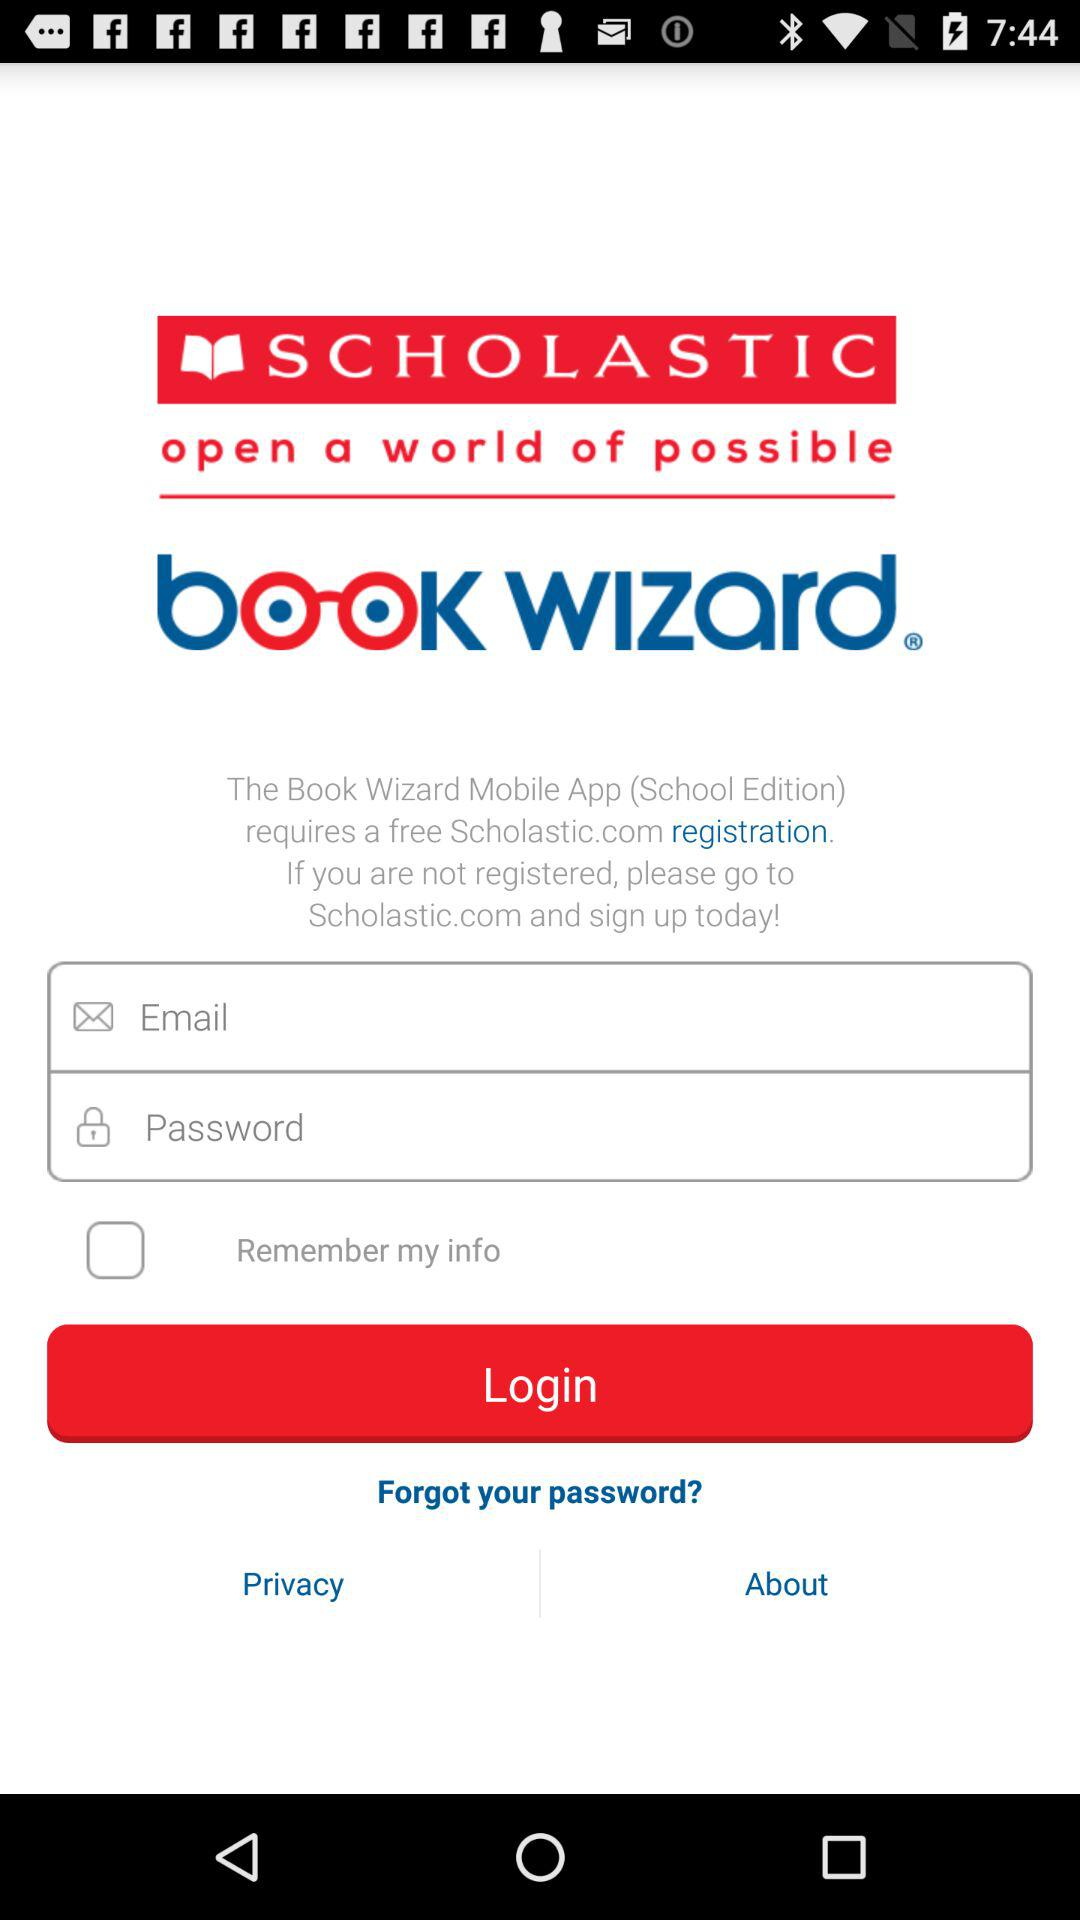What is the app name? The app name is "Book Wizard". 